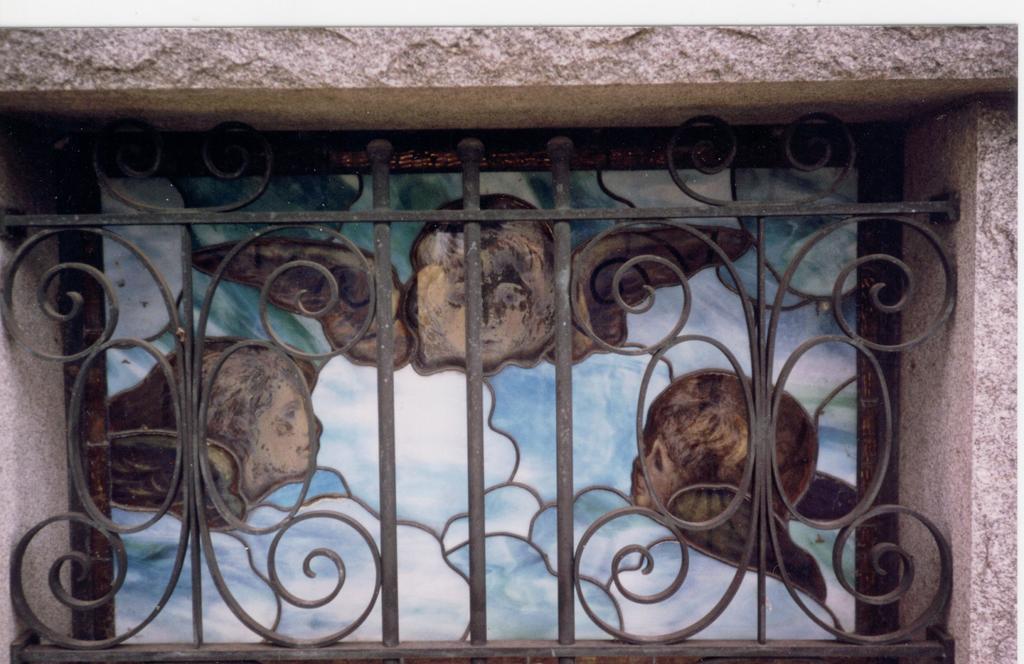Can you describe this image briefly? Here in this picture we can see a ventilator window present over a place and we can also see a frame present near the window. 